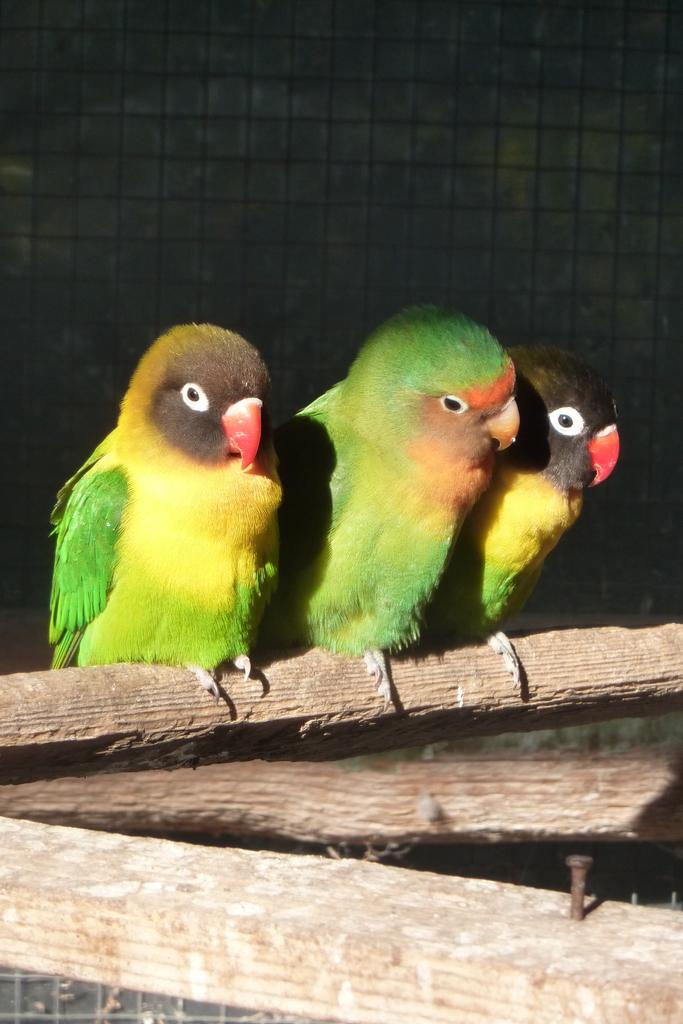What type of animals are in the center of the image? There are parrots in the center of the image. What objects can be seen in the image besides the parrots? There are wooden logs visible in the image. What can be seen in the background of the image? There is a mesh visible in the background of the image. What type of vein is visible in the image? There is no vein present in the image. Is there any sleet visible in the image? There is no sleet present in the image. 